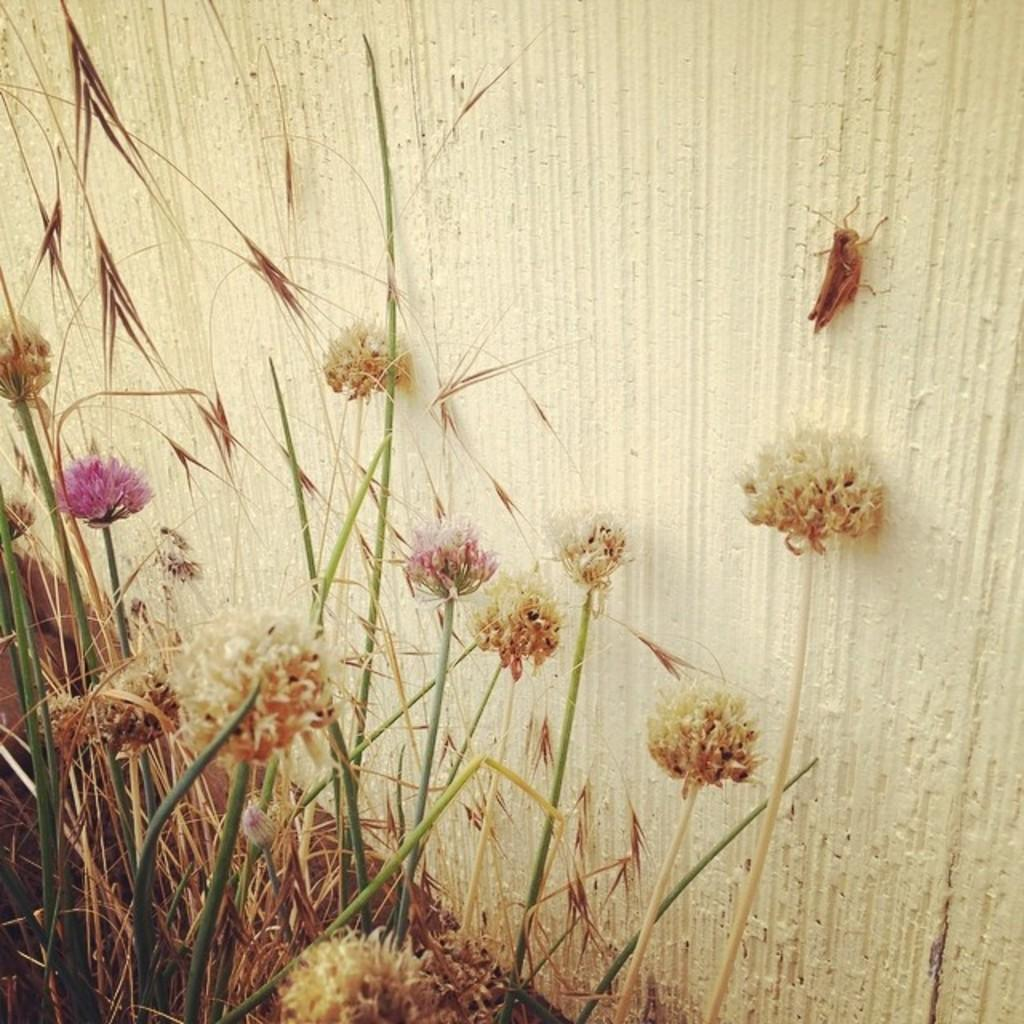What type of plants can be seen in the image? There are many flowers in the image. What type of vegetation is at the bottom of the image? There is grass at the bottom of the image. What structure is present in the middle of the image? There is a wall in the middle of the image. What direction is the wind blowing in the image? There is no indication of wind in the image, so it cannot be determined from the image. 